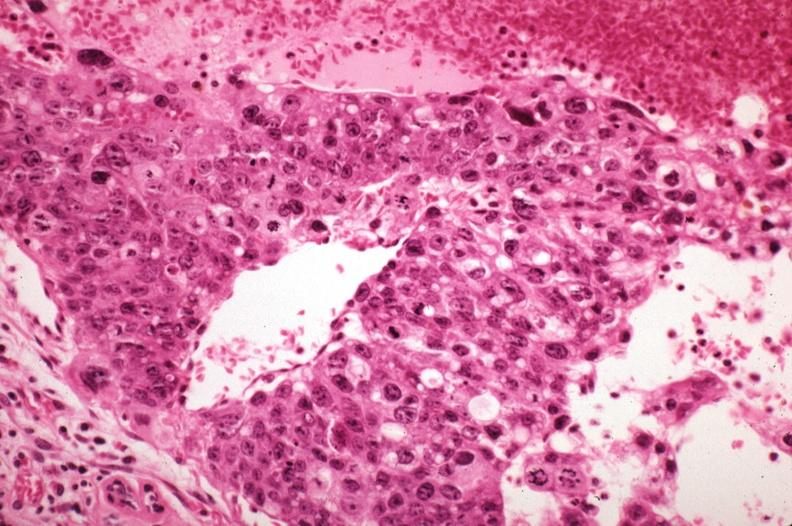s breast present?
Answer the question using a single word or phrase. Yes 